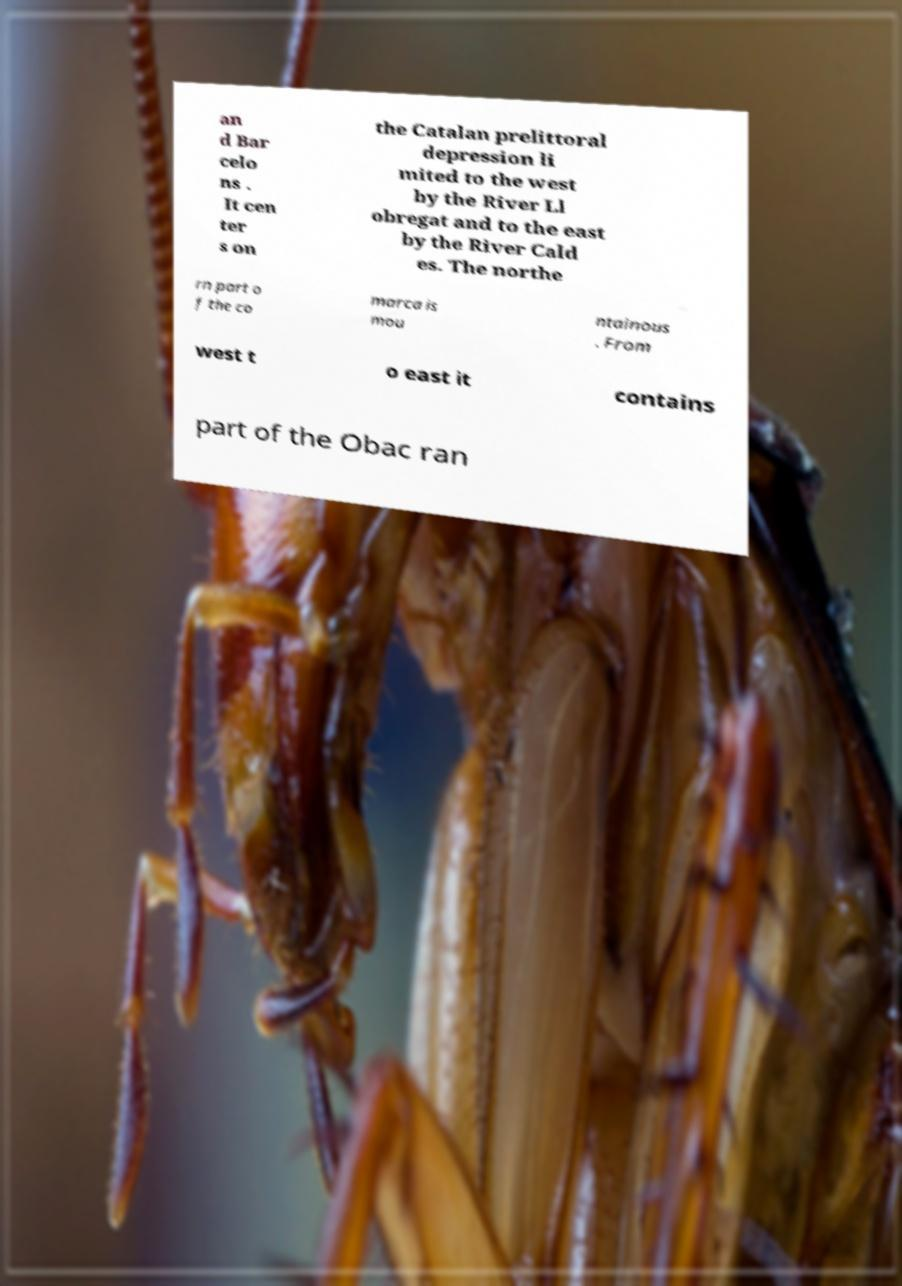Could you extract and type out the text from this image? an d Bar celo ns . It cen ter s on the Catalan prelittoral depression li mited to the west by the River Ll obregat and to the east by the River Cald es. The northe rn part o f the co marca is mou ntainous . From west t o east it contains part of the Obac ran 